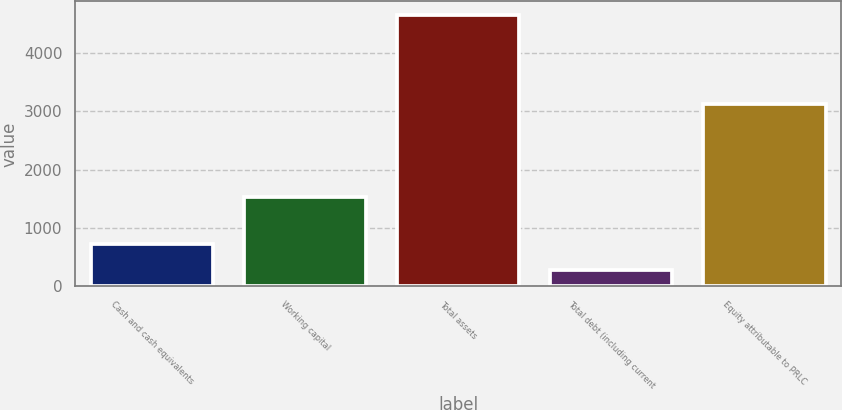Convert chart to OTSL. <chart><loc_0><loc_0><loc_500><loc_500><bar_chart><fcel>Cash and cash equivalents<fcel>Working capital<fcel>Total assets<fcel>Total debt (including current<fcel>Equity attributable to PRLC<nl><fcel>718.78<fcel>1528.5<fcel>4648.9<fcel>282.1<fcel>3116.6<nl></chart> 